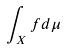<formula> <loc_0><loc_0><loc_500><loc_500>\int _ { X } f d \mu</formula> 